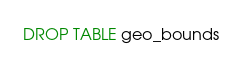<code> <loc_0><loc_0><loc_500><loc_500><_SQL_>DROP TABLE geo_bounds
</code> 